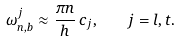Convert formula to latex. <formula><loc_0><loc_0><loc_500><loc_500>\omega _ { n , b } ^ { j } \approx \frac { \pi n } { h } \, c _ { j } , \quad j = l , t .</formula> 